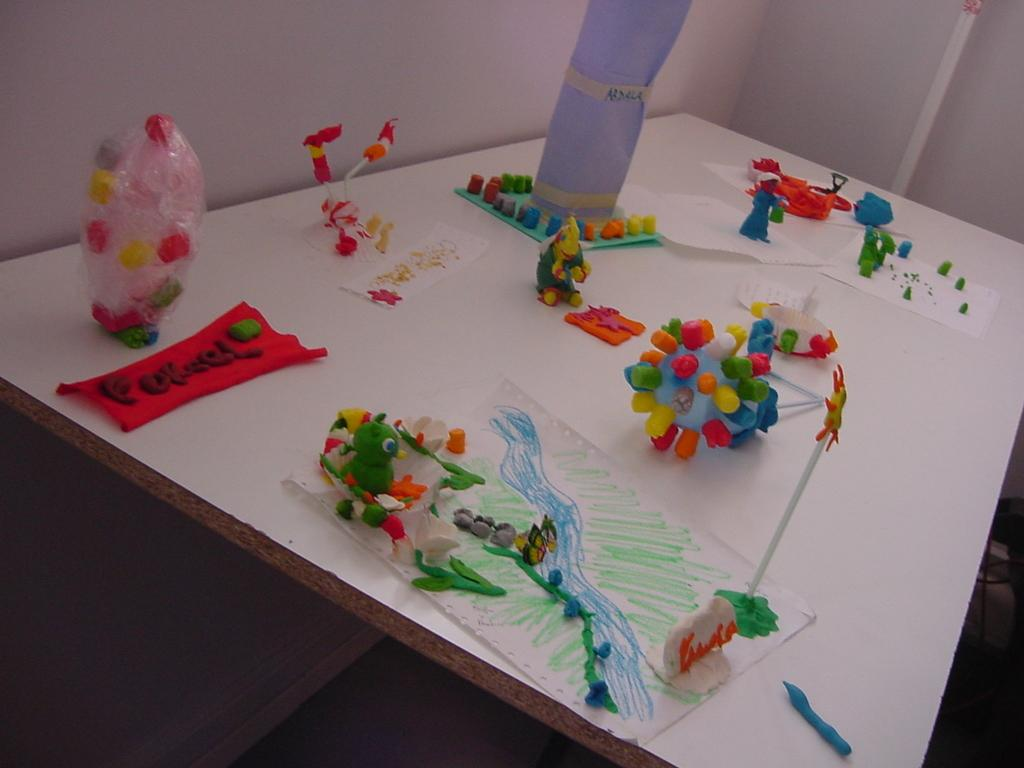What type of furniture is present in the image? There is a table in the image. What else can be seen in the image besides the table? There are walls and a rod in the image. What is on the table in the image? There are crafts on the table. How many trees are visible in the image? There are no trees visible in the image. What type of pot is used for the crafts on the table? There is no pot mentioned or visible in the image. 